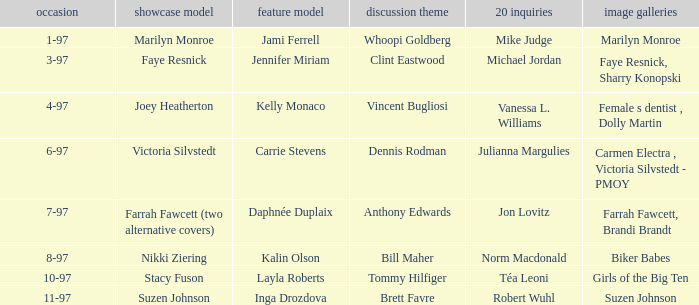Write the full table. {'header': ['occasion', 'showcase model', 'feature model', 'discussion theme', '20 inquiries', 'image galleries'], 'rows': [['1-97', 'Marilyn Monroe', 'Jami Ferrell', 'Whoopi Goldberg', 'Mike Judge', 'Marilyn Monroe'], ['3-97', 'Faye Resnick', 'Jennifer Miriam', 'Clint Eastwood', 'Michael Jordan', 'Faye Resnick, Sharry Konopski'], ['4-97', 'Joey Heatherton', 'Kelly Monaco', 'Vincent Bugliosi', 'Vanessa L. Williams', 'Female s dentist , Dolly Martin'], ['6-97', 'Victoria Silvstedt', 'Carrie Stevens', 'Dennis Rodman', 'Julianna Margulies', 'Carmen Electra , Victoria Silvstedt - PMOY'], ['7-97', 'Farrah Fawcett (two alternative covers)', 'Daphnée Duplaix', 'Anthony Edwards', 'Jon Lovitz', 'Farrah Fawcett, Brandi Brandt'], ['8-97', 'Nikki Ziering', 'Kalin Olson', 'Bill Maher', 'Norm Macdonald', 'Biker Babes'], ['10-97', 'Stacy Fuson', 'Layla Roberts', 'Tommy Hilfiger', 'Téa Leoni', 'Girls of the Big Ten'], ['11-97', 'Suzen Johnson', 'Inga Drozdova', 'Brett Favre', 'Robert Wuhl', 'Suzen Johnson']]} What is the name of the cover model on 3-97? Faye Resnick. 